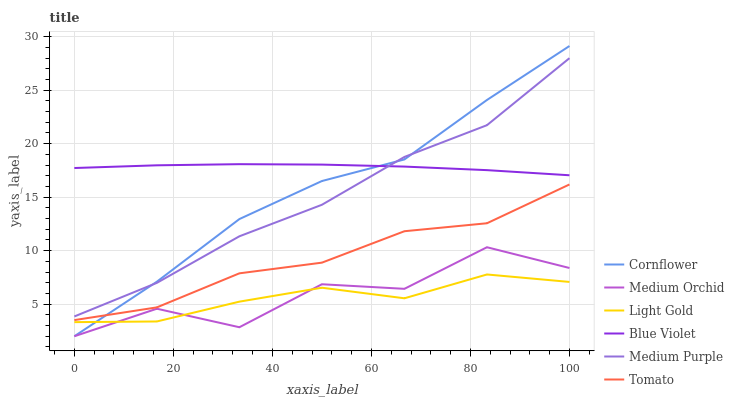Does Light Gold have the minimum area under the curve?
Answer yes or no. Yes. Does Blue Violet have the maximum area under the curve?
Answer yes or no. Yes. Does Cornflower have the minimum area under the curve?
Answer yes or no. No. Does Cornflower have the maximum area under the curve?
Answer yes or no. No. Is Blue Violet the smoothest?
Answer yes or no. Yes. Is Medium Orchid the roughest?
Answer yes or no. Yes. Is Cornflower the smoothest?
Answer yes or no. No. Is Cornflower the roughest?
Answer yes or no. No. Does Cornflower have the lowest value?
Answer yes or no. Yes. Does Medium Purple have the lowest value?
Answer yes or no. No. Does Cornflower have the highest value?
Answer yes or no. Yes. Does Medium Orchid have the highest value?
Answer yes or no. No. Is Medium Orchid less than Blue Violet?
Answer yes or no. Yes. Is Blue Violet greater than Light Gold?
Answer yes or no. Yes. Does Blue Violet intersect Cornflower?
Answer yes or no. Yes. Is Blue Violet less than Cornflower?
Answer yes or no. No. Is Blue Violet greater than Cornflower?
Answer yes or no. No. Does Medium Orchid intersect Blue Violet?
Answer yes or no. No. 